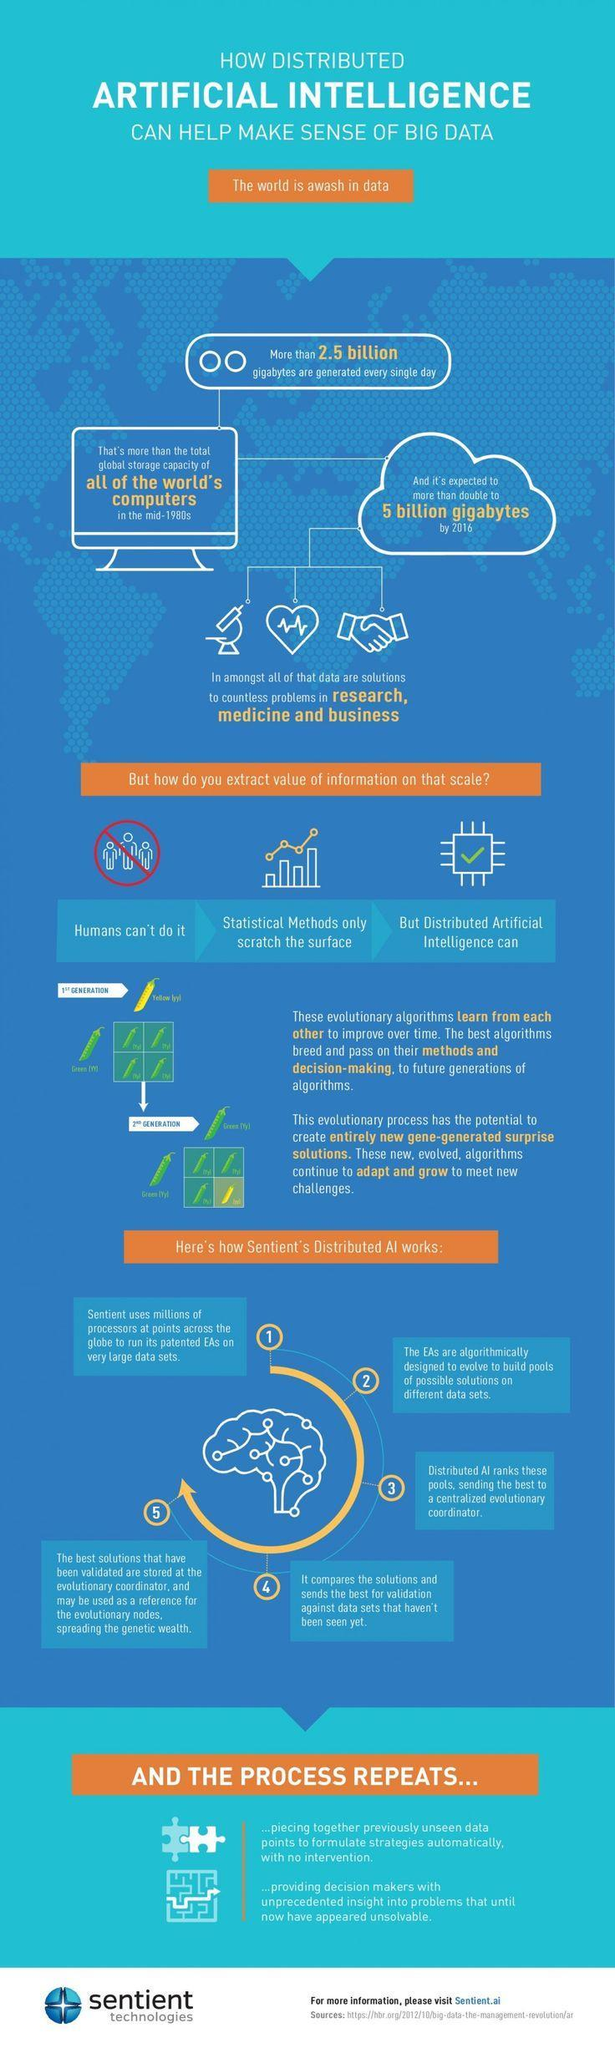Where does the Distributed AI send the best of the ranked pools?
Answer the question with a short phrase. centralized evolutionary coordinator what is the best way to extract value of information? using distributed artificial intelligence 